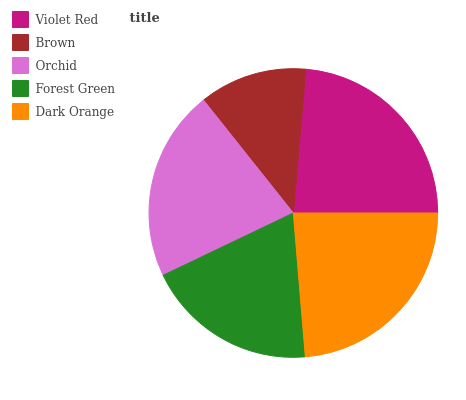Is Brown the minimum?
Answer yes or no. Yes. Is Dark Orange the maximum?
Answer yes or no. Yes. Is Orchid the minimum?
Answer yes or no. No. Is Orchid the maximum?
Answer yes or no. No. Is Orchid greater than Brown?
Answer yes or no. Yes. Is Brown less than Orchid?
Answer yes or no. Yes. Is Brown greater than Orchid?
Answer yes or no. No. Is Orchid less than Brown?
Answer yes or no. No. Is Orchid the high median?
Answer yes or no. Yes. Is Orchid the low median?
Answer yes or no. Yes. Is Dark Orange the high median?
Answer yes or no. No. Is Violet Red the low median?
Answer yes or no. No. 